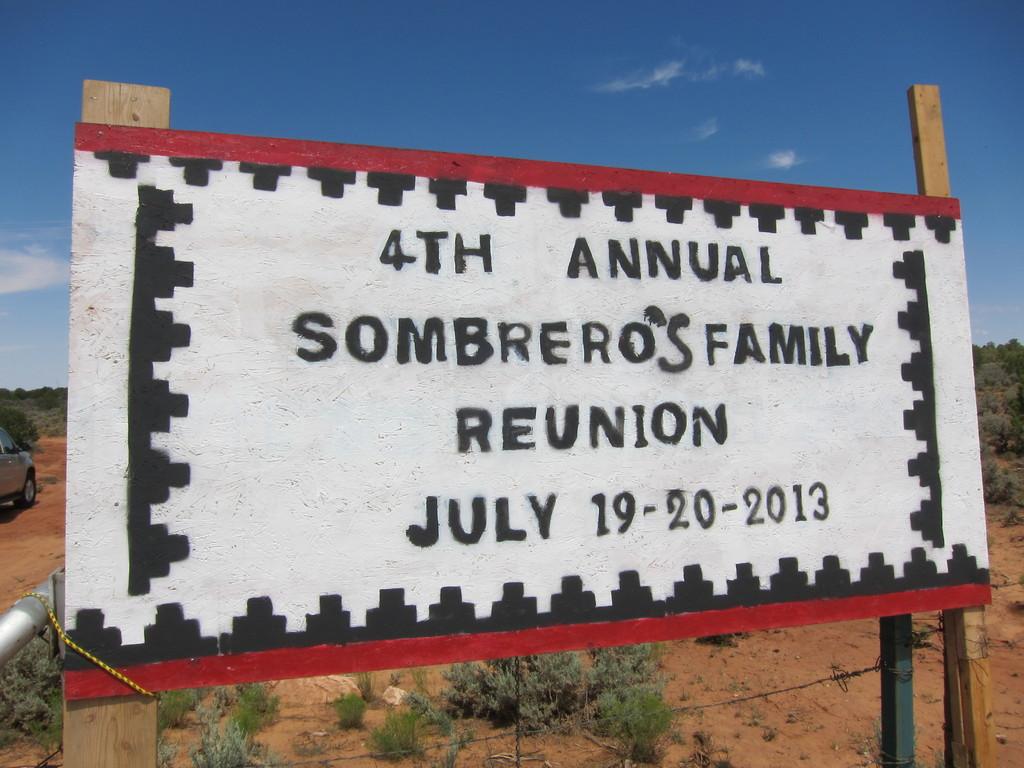What number is this reunion?
Ensure brevity in your answer.  4th. 